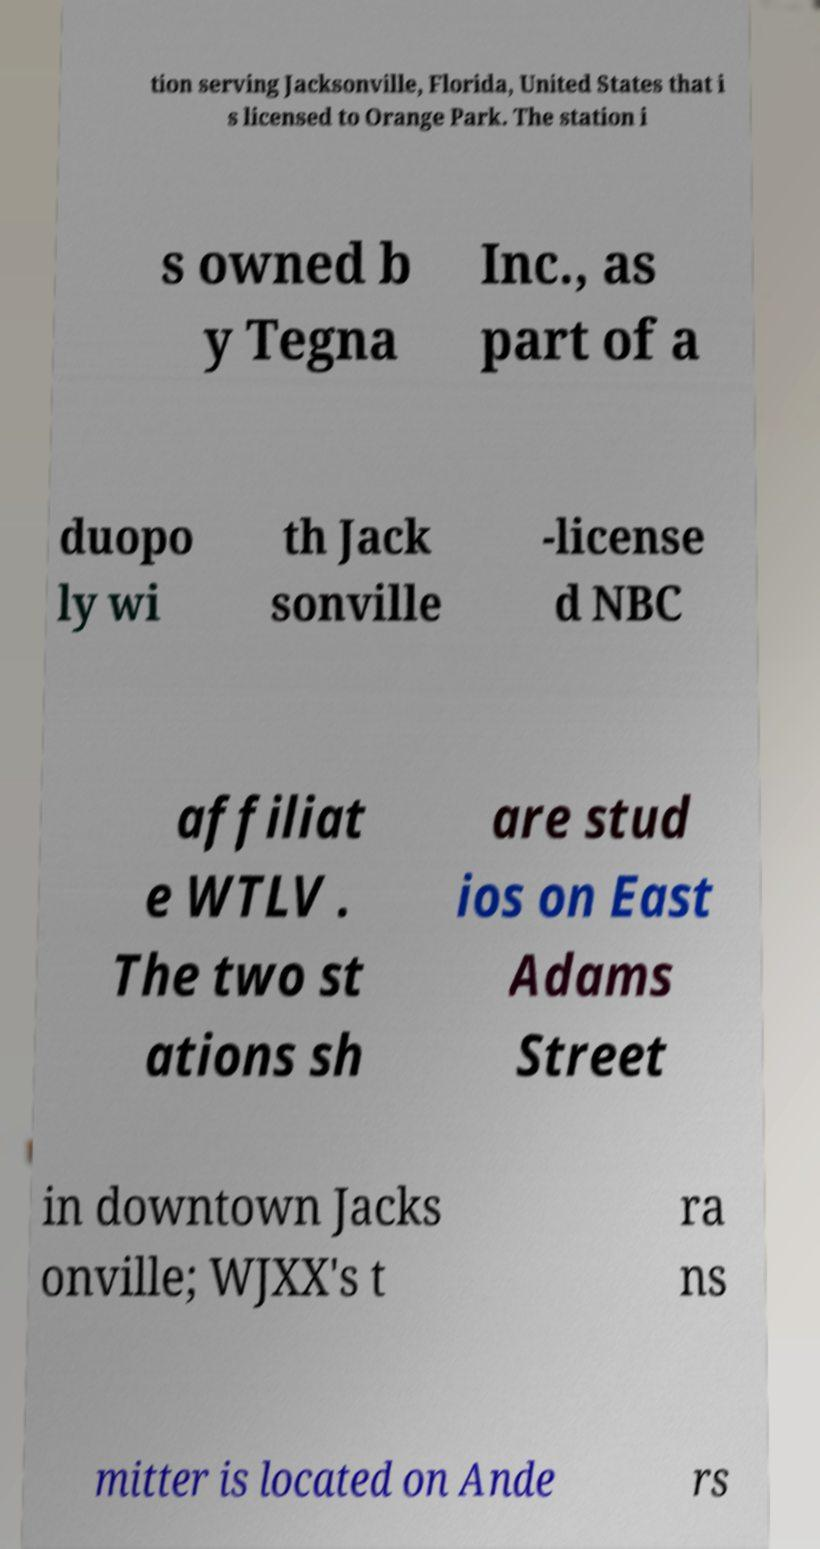Can you read and provide the text displayed in the image?This photo seems to have some interesting text. Can you extract and type it out for me? tion serving Jacksonville, Florida, United States that i s licensed to Orange Park. The station i s owned b y Tegna Inc., as part of a duopo ly wi th Jack sonville -license d NBC affiliat e WTLV . The two st ations sh are stud ios on East Adams Street in downtown Jacks onville; WJXX's t ra ns mitter is located on Ande rs 